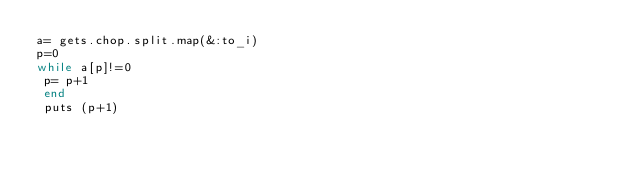Convert code to text. <code><loc_0><loc_0><loc_500><loc_500><_Ruby_>a= gets.chop.split.map(&:to_i)
p=0
while a[p]!=0
 p= p+1
 end
 puts (p+1)</code> 